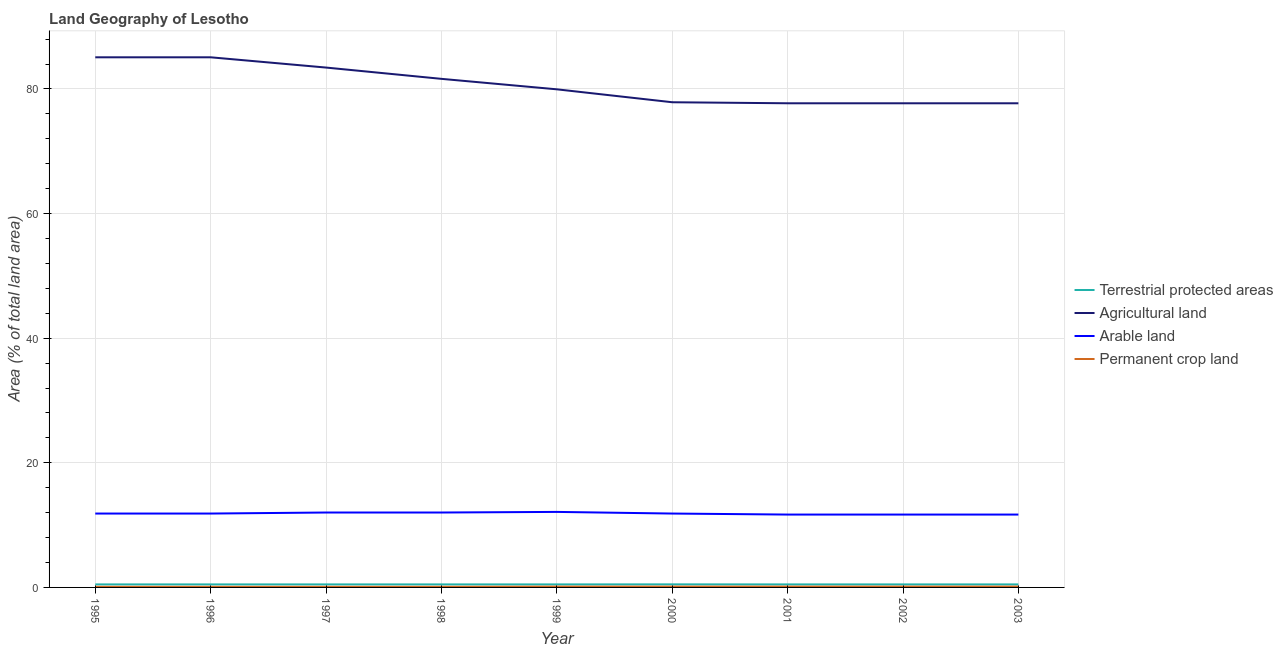How many different coloured lines are there?
Offer a very short reply. 4. Is the number of lines equal to the number of legend labels?
Your response must be concise. Yes. What is the percentage of area under agricultural land in 2002?
Offer a terse response. 77.7. Across all years, what is the maximum percentage of area under permanent crop land?
Your answer should be compact. 0.13. Across all years, what is the minimum percentage of area under agricultural land?
Your response must be concise. 77.7. In which year was the percentage of area under agricultural land maximum?
Offer a terse response. 1995. What is the total percentage of area under permanent crop land in the graph?
Provide a succinct answer. 1.05. What is the difference between the percentage of area under agricultural land in 2001 and that in 2003?
Keep it short and to the point. 0. What is the difference between the percentage of area under permanent crop land in 1996 and the percentage of area under agricultural land in 2003?
Your response must be concise. -77.6. What is the average percentage of area under arable land per year?
Offer a very short reply. 11.87. In the year 1995, what is the difference between the percentage of area under arable land and percentage of area under permanent crop land?
Provide a short and direct response. 11.76. What is the ratio of the percentage of area under agricultural land in 1996 to that in 2002?
Keep it short and to the point. 1.09. Is the difference between the percentage of area under permanent crop land in 1998 and 1999 greater than the difference between the percentage of area under arable land in 1998 and 1999?
Keep it short and to the point. Yes. What is the difference between the highest and the second highest percentage of land under terrestrial protection?
Offer a very short reply. 0.01. What is the difference between the highest and the lowest percentage of land under terrestrial protection?
Provide a short and direct response. 0.01. Is it the case that in every year, the sum of the percentage of land under terrestrial protection and percentage of area under agricultural land is greater than the percentage of area under arable land?
Keep it short and to the point. Yes. Is the percentage of area under arable land strictly greater than the percentage of area under agricultural land over the years?
Make the answer very short. No. Is the percentage of area under agricultural land strictly less than the percentage of land under terrestrial protection over the years?
Provide a succinct answer. No. How many lines are there?
Provide a succinct answer. 4. How many years are there in the graph?
Your response must be concise. 9. What is the difference between two consecutive major ticks on the Y-axis?
Offer a terse response. 20. Does the graph contain grids?
Your response must be concise. Yes. Where does the legend appear in the graph?
Provide a short and direct response. Center right. How many legend labels are there?
Ensure brevity in your answer.  4. What is the title of the graph?
Your answer should be compact. Land Geography of Lesotho. Does "Ease of arranging shipments" appear as one of the legend labels in the graph?
Offer a very short reply. No. What is the label or title of the Y-axis?
Offer a very short reply. Area (% of total land area). What is the Area (% of total land area) in Terrestrial protected areas in 1995?
Provide a succinct answer. 0.49. What is the Area (% of total land area) of Agricultural land in 1995?
Keep it short and to the point. 85.08. What is the Area (% of total land area) in Arable land in 1995?
Offer a terse response. 11.86. What is the Area (% of total land area) in Permanent crop land in 1995?
Offer a terse response. 0.1. What is the Area (% of total land area) of Terrestrial protected areas in 1996?
Offer a very short reply. 0.49. What is the Area (% of total land area) of Agricultural land in 1996?
Offer a very short reply. 85.08. What is the Area (% of total land area) of Arable land in 1996?
Ensure brevity in your answer.  11.86. What is the Area (% of total land area) in Permanent crop land in 1996?
Ensure brevity in your answer.  0.1. What is the Area (% of total land area) in Terrestrial protected areas in 1997?
Offer a terse response. 0.49. What is the Area (% of total land area) in Agricultural land in 1997?
Offer a terse response. 83.43. What is the Area (% of total land area) of Arable land in 1997?
Offer a terse response. 12.02. What is the Area (% of total land area) of Permanent crop land in 1997?
Offer a very short reply. 0.1. What is the Area (% of total land area) in Terrestrial protected areas in 1998?
Offer a very short reply. 0.49. What is the Area (% of total land area) in Agricultural land in 1998?
Give a very brief answer. 81.62. What is the Area (% of total land area) of Arable land in 1998?
Make the answer very short. 12.02. What is the Area (% of total land area) in Permanent crop land in 1998?
Keep it short and to the point. 0.1. What is the Area (% of total land area) in Terrestrial protected areas in 1999?
Your answer should be compact. 0.49. What is the Area (% of total land area) of Agricultural land in 1999?
Offer a terse response. 79.94. What is the Area (% of total land area) of Arable land in 1999?
Provide a succinct answer. 12.12. What is the Area (% of total land area) of Permanent crop land in 1999?
Make the answer very short. 0.13. What is the Area (% of total land area) of Terrestrial protected areas in 2000?
Make the answer very short. 0.49. What is the Area (% of total land area) in Agricultural land in 2000?
Make the answer very short. 77.87. What is the Area (% of total land area) in Arable land in 2000?
Your response must be concise. 11.86. What is the Area (% of total land area) of Permanent crop land in 2000?
Ensure brevity in your answer.  0.13. What is the Area (% of total land area) of Terrestrial protected areas in 2001?
Make the answer very short. 0.49. What is the Area (% of total land area) in Agricultural land in 2001?
Your answer should be compact. 77.7. What is the Area (% of total land area) of Arable land in 2001?
Make the answer very short. 11.69. What is the Area (% of total land area) in Permanent crop land in 2001?
Ensure brevity in your answer.  0.13. What is the Area (% of total land area) in Terrestrial protected areas in 2002?
Provide a succinct answer. 0.49. What is the Area (% of total land area) of Agricultural land in 2002?
Offer a terse response. 77.7. What is the Area (% of total land area) of Arable land in 2002?
Offer a very short reply. 11.69. What is the Area (% of total land area) in Permanent crop land in 2002?
Your response must be concise. 0.13. What is the Area (% of total land area) in Terrestrial protected areas in 2003?
Offer a terse response. 0.49. What is the Area (% of total land area) of Agricultural land in 2003?
Offer a very short reply. 77.7. What is the Area (% of total land area) in Arable land in 2003?
Your response must be concise. 11.69. What is the Area (% of total land area) in Permanent crop land in 2003?
Keep it short and to the point. 0.13. Across all years, what is the maximum Area (% of total land area) of Terrestrial protected areas?
Make the answer very short. 0.49. Across all years, what is the maximum Area (% of total land area) in Agricultural land?
Your response must be concise. 85.08. Across all years, what is the maximum Area (% of total land area) in Arable land?
Your response must be concise. 12.12. Across all years, what is the maximum Area (% of total land area) of Permanent crop land?
Provide a short and direct response. 0.13. Across all years, what is the minimum Area (% of total land area) in Terrestrial protected areas?
Your response must be concise. 0.49. Across all years, what is the minimum Area (% of total land area) in Agricultural land?
Your answer should be compact. 77.7. Across all years, what is the minimum Area (% of total land area) in Arable land?
Your response must be concise. 11.69. Across all years, what is the minimum Area (% of total land area) in Permanent crop land?
Give a very brief answer. 0.1. What is the total Area (% of total land area) in Terrestrial protected areas in the graph?
Your answer should be compact. 4.37. What is the total Area (% of total land area) in Agricultural land in the graph?
Your response must be concise. 726.12. What is the total Area (% of total land area) in Arable land in the graph?
Make the answer very short. 106.82. What is the total Area (% of total land area) of Permanent crop land in the graph?
Ensure brevity in your answer.  1.05. What is the difference between the Area (% of total land area) in Terrestrial protected areas in 1995 and that in 1996?
Make the answer very short. 0. What is the difference between the Area (% of total land area) in Permanent crop land in 1995 and that in 1996?
Provide a short and direct response. 0. What is the difference between the Area (% of total land area) of Agricultural land in 1995 and that in 1997?
Offer a terse response. 1.65. What is the difference between the Area (% of total land area) of Arable land in 1995 and that in 1997?
Your answer should be very brief. -0.16. What is the difference between the Area (% of total land area) in Permanent crop land in 1995 and that in 1997?
Keep it short and to the point. 0. What is the difference between the Area (% of total land area) in Agricultural land in 1995 and that in 1998?
Your response must be concise. 3.46. What is the difference between the Area (% of total land area) of Arable land in 1995 and that in 1998?
Provide a succinct answer. -0.16. What is the difference between the Area (% of total land area) in Agricultural land in 1995 and that in 1999?
Your response must be concise. 5.14. What is the difference between the Area (% of total land area) in Arable land in 1995 and that in 1999?
Your answer should be compact. -0.26. What is the difference between the Area (% of total land area) in Permanent crop land in 1995 and that in 1999?
Your response must be concise. -0.03. What is the difference between the Area (% of total land area) in Terrestrial protected areas in 1995 and that in 2000?
Provide a short and direct response. -0.01. What is the difference between the Area (% of total land area) in Agricultural land in 1995 and that in 2000?
Offer a terse response. 7.21. What is the difference between the Area (% of total land area) in Permanent crop land in 1995 and that in 2000?
Provide a succinct answer. -0.03. What is the difference between the Area (% of total land area) of Terrestrial protected areas in 1995 and that in 2001?
Your response must be concise. 0. What is the difference between the Area (% of total land area) in Agricultural land in 1995 and that in 2001?
Make the answer very short. 7.38. What is the difference between the Area (% of total land area) of Arable land in 1995 and that in 2001?
Provide a succinct answer. 0.16. What is the difference between the Area (% of total land area) of Permanent crop land in 1995 and that in 2001?
Give a very brief answer. -0.03. What is the difference between the Area (% of total land area) of Agricultural land in 1995 and that in 2002?
Keep it short and to the point. 7.38. What is the difference between the Area (% of total land area) in Arable land in 1995 and that in 2002?
Provide a short and direct response. 0.16. What is the difference between the Area (% of total land area) of Permanent crop land in 1995 and that in 2002?
Your response must be concise. -0.03. What is the difference between the Area (% of total land area) in Agricultural land in 1995 and that in 2003?
Give a very brief answer. 7.38. What is the difference between the Area (% of total land area) in Arable land in 1995 and that in 2003?
Make the answer very short. 0.16. What is the difference between the Area (% of total land area) of Permanent crop land in 1995 and that in 2003?
Ensure brevity in your answer.  -0.03. What is the difference between the Area (% of total land area) of Agricultural land in 1996 and that in 1997?
Keep it short and to the point. 1.65. What is the difference between the Area (% of total land area) of Arable land in 1996 and that in 1997?
Make the answer very short. -0.16. What is the difference between the Area (% of total land area) in Terrestrial protected areas in 1996 and that in 1998?
Offer a terse response. 0. What is the difference between the Area (% of total land area) of Agricultural land in 1996 and that in 1998?
Provide a succinct answer. 3.46. What is the difference between the Area (% of total land area) in Arable land in 1996 and that in 1998?
Your answer should be compact. -0.16. What is the difference between the Area (% of total land area) of Permanent crop land in 1996 and that in 1998?
Offer a terse response. 0. What is the difference between the Area (% of total land area) in Terrestrial protected areas in 1996 and that in 1999?
Ensure brevity in your answer.  0. What is the difference between the Area (% of total land area) of Agricultural land in 1996 and that in 1999?
Offer a terse response. 5.14. What is the difference between the Area (% of total land area) of Arable land in 1996 and that in 1999?
Your answer should be compact. -0.26. What is the difference between the Area (% of total land area) in Permanent crop land in 1996 and that in 1999?
Make the answer very short. -0.03. What is the difference between the Area (% of total land area) of Terrestrial protected areas in 1996 and that in 2000?
Your response must be concise. -0.01. What is the difference between the Area (% of total land area) of Agricultural land in 1996 and that in 2000?
Your answer should be compact. 7.21. What is the difference between the Area (% of total land area) of Arable land in 1996 and that in 2000?
Offer a terse response. 0. What is the difference between the Area (% of total land area) of Permanent crop land in 1996 and that in 2000?
Offer a very short reply. -0.03. What is the difference between the Area (% of total land area) of Terrestrial protected areas in 1996 and that in 2001?
Offer a very short reply. 0. What is the difference between the Area (% of total land area) of Agricultural land in 1996 and that in 2001?
Your answer should be compact. 7.38. What is the difference between the Area (% of total land area) of Arable land in 1996 and that in 2001?
Keep it short and to the point. 0.16. What is the difference between the Area (% of total land area) of Permanent crop land in 1996 and that in 2001?
Keep it short and to the point. -0.03. What is the difference between the Area (% of total land area) in Agricultural land in 1996 and that in 2002?
Your answer should be very brief. 7.38. What is the difference between the Area (% of total land area) of Arable land in 1996 and that in 2002?
Give a very brief answer. 0.16. What is the difference between the Area (% of total land area) in Permanent crop land in 1996 and that in 2002?
Give a very brief answer. -0.03. What is the difference between the Area (% of total land area) in Terrestrial protected areas in 1996 and that in 2003?
Your response must be concise. 0. What is the difference between the Area (% of total land area) in Agricultural land in 1996 and that in 2003?
Keep it short and to the point. 7.38. What is the difference between the Area (% of total land area) in Arable land in 1996 and that in 2003?
Ensure brevity in your answer.  0.16. What is the difference between the Area (% of total land area) in Permanent crop land in 1996 and that in 2003?
Your answer should be compact. -0.03. What is the difference between the Area (% of total land area) of Terrestrial protected areas in 1997 and that in 1998?
Keep it short and to the point. 0. What is the difference between the Area (% of total land area) of Agricultural land in 1997 and that in 1998?
Your answer should be very brief. 1.81. What is the difference between the Area (% of total land area) in Arable land in 1997 and that in 1998?
Your answer should be very brief. 0. What is the difference between the Area (% of total land area) in Permanent crop land in 1997 and that in 1998?
Provide a succinct answer. 0. What is the difference between the Area (% of total land area) in Terrestrial protected areas in 1997 and that in 1999?
Provide a short and direct response. 0. What is the difference between the Area (% of total land area) of Agricultural land in 1997 and that in 1999?
Your answer should be very brief. 3.49. What is the difference between the Area (% of total land area) of Arable land in 1997 and that in 1999?
Offer a very short reply. -0.1. What is the difference between the Area (% of total land area) in Permanent crop land in 1997 and that in 1999?
Provide a short and direct response. -0.03. What is the difference between the Area (% of total land area) in Terrestrial protected areas in 1997 and that in 2000?
Offer a terse response. -0.01. What is the difference between the Area (% of total land area) of Agricultural land in 1997 and that in 2000?
Offer a very short reply. 5.57. What is the difference between the Area (% of total land area) in Arable land in 1997 and that in 2000?
Provide a succinct answer. 0.16. What is the difference between the Area (% of total land area) in Permanent crop land in 1997 and that in 2000?
Offer a terse response. -0.03. What is the difference between the Area (% of total land area) of Terrestrial protected areas in 1997 and that in 2001?
Provide a succinct answer. 0. What is the difference between the Area (% of total land area) in Agricultural land in 1997 and that in 2001?
Provide a short and direct response. 5.73. What is the difference between the Area (% of total land area) in Arable land in 1997 and that in 2001?
Your response must be concise. 0.33. What is the difference between the Area (% of total land area) in Permanent crop land in 1997 and that in 2001?
Your response must be concise. -0.03. What is the difference between the Area (% of total land area) of Agricultural land in 1997 and that in 2002?
Your answer should be very brief. 5.73. What is the difference between the Area (% of total land area) in Arable land in 1997 and that in 2002?
Your answer should be compact. 0.33. What is the difference between the Area (% of total land area) of Permanent crop land in 1997 and that in 2002?
Offer a very short reply. -0.03. What is the difference between the Area (% of total land area) in Terrestrial protected areas in 1997 and that in 2003?
Ensure brevity in your answer.  0. What is the difference between the Area (% of total land area) of Agricultural land in 1997 and that in 2003?
Provide a succinct answer. 5.73. What is the difference between the Area (% of total land area) of Arable land in 1997 and that in 2003?
Your answer should be very brief. 0.33. What is the difference between the Area (% of total land area) of Permanent crop land in 1997 and that in 2003?
Provide a short and direct response. -0.03. What is the difference between the Area (% of total land area) of Agricultural land in 1998 and that in 1999?
Give a very brief answer. 1.68. What is the difference between the Area (% of total land area) of Arable land in 1998 and that in 1999?
Your answer should be very brief. -0.1. What is the difference between the Area (% of total land area) of Permanent crop land in 1998 and that in 1999?
Make the answer very short. -0.03. What is the difference between the Area (% of total land area) in Terrestrial protected areas in 1998 and that in 2000?
Provide a succinct answer. -0.01. What is the difference between the Area (% of total land area) in Agricultural land in 1998 and that in 2000?
Give a very brief answer. 3.75. What is the difference between the Area (% of total land area) in Arable land in 1998 and that in 2000?
Ensure brevity in your answer.  0.16. What is the difference between the Area (% of total land area) in Permanent crop land in 1998 and that in 2000?
Offer a terse response. -0.03. What is the difference between the Area (% of total land area) in Agricultural land in 1998 and that in 2001?
Offer a terse response. 3.92. What is the difference between the Area (% of total land area) of Arable land in 1998 and that in 2001?
Give a very brief answer. 0.33. What is the difference between the Area (% of total land area) in Permanent crop land in 1998 and that in 2001?
Offer a very short reply. -0.03. What is the difference between the Area (% of total land area) of Agricultural land in 1998 and that in 2002?
Provide a succinct answer. 3.92. What is the difference between the Area (% of total land area) in Arable land in 1998 and that in 2002?
Give a very brief answer. 0.33. What is the difference between the Area (% of total land area) of Permanent crop land in 1998 and that in 2002?
Provide a succinct answer. -0.03. What is the difference between the Area (% of total land area) in Agricultural land in 1998 and that in 2003?
Your response must be concise. 3.92. What is the difference between the Area (% of total land area) of Arable land in 1998 and that in 2003?
Make the answer very short. 0.33. What is the difference between the Area (% of total land area) of Permanent crop land in 1998 and that in 2003?
Your answer should be compact. -0.03. What is the difference between the Area (% of total land area) in Terrestrial protected areas in 1999 and that in 2000?
Provide a succinct answer. -0.01. What is the difference between the Area (% of total land area) in Agricultural land in 1999 and that in 2000?
Provide a succinct answer. 2.08. What is the difference between the Area (% of total land area) in Arable land in 1999 and that in 2000?
Give a very brief answer. 0.26. What is the difference between the Area (% of total land area) of Agricultural land in 1999 and that in 2001?
Offer a terse response. 2.24. What is the difference between the Area (% of total land area) of Arable land in 1999 and that in 2001?
Offer a very short reply. 0.43. What is the difference between the Area (% of total land area) of Terrestrial protected areas in 1999 and that in 2002?
Your response must be concise. 0. What is the difference between the Area (% of total land area) in Agricultural land in 1999 and that in 2002?
Offer a terse response. 2.24. What is the difference between the Area (% of total land area) of Arable land in 1999 and that in 2002?
Provide a succinct answer. 0.43. What is the difference between the Area (% of total land area) of Terrestrial protected areas in 1999 and that in 2003?
Provide a succinct answer. 0. What is the difference between the Area (% of total land area) in Agricultural land in 1999 and that in 2003?
Make the answer very short. 2.24. What is the difference between the Area (% of total land area) in Arable land in 1999 and that in 2003?
Provide a short and direct response. 0.43. What is the difference between the Area (% of total land area) of Terrestrial protected areas in 2000 and that in 2001?
Ensure brevity in your answer.  0.01. What is the difference between the Area (% of total land area) of Agricultural land in 2000 and that in 2001?
Provide a succinct answer. 0.16. What is the difference between the Area (% of total land area) of Arable land in 2000 and that in 2001?
Offer a terse response. 0.16. What is the difference between the Area (% of total land area) of Permanent crop land in 2000 and that in 2001?
Your answer should be very brief. 0. What is the difference between the Area (% of total land area) of Terrestrial protected areas in 2000 and that in 2002?
Provide a short and direct response. 0.01. What is the difference between the Area (% of total land area) in Agricultural land in 2000 and that in 2002?
Offer a very short reply. 0.16. What is the difference between the Area (% of total land area) in Arable land in 2000 and that in 2002?
Offer a very short reply. 0.16. What is the difference between the Area (% of total land area) of Terrestrial protected areas in 2000 and that in 2003?
Offer a terse response. 0.01. What is the difference between the Area (% of total land area) of Agricultural land in 2000 and that in 2003?
Provide a succinct answer. 0.16. What is the difference between the Area (% of total land area) in Arable land in 2000 and that in 2003?
Ensure brevity in your answer.  0.16. What is the difference between the Area (% of total land area) in Permanent crop land in 2001 and that in 2002?
Offer a very short reply. 0. What is the difference between the Area (% of total land area) in Terrestrial protected areas in 2001 and that in 2003?
Offer a terse response. 0. What is the difference between the Area (% of total land area) of Agricultural land in 2001 and that in 2003?
Provide a succinct answer. 0. What is the difference between the Area (% of total land area) in Permanent crop land in 2001 and that in 2003?
Give a very brief answer. 0. What is the difference between the Area (% of total land area) of Arable land in 2002 and that in 2003?
Your answer should be compact. 0. What is the difference between the Area (% of total land area) in Permanent crop land in 2002 and that in 2003?
Offer a very short reply. 0. What is the difference between the Area (% of total land area) in Terrestrial protected areas in 1995 and the Area (% of total land area) in Agricultural land in 1996?
Offer a terse response. -84.59. What is the difference between the Area (% of total land area) in Terrestrial protected areas in 1995 and the Area (% of total land area) in Arable land in 1996?
Ensure brevity in your answer.  -11.37. What is the difference between the Area (% of total land area) of Terrestrial protected areas in 1995 and the Area (% of total land area) of Permanent crop land in 1996?
Your answer should be very brief. 0.39. What is the difference between the Area (% of total land area) of Agricultural land in 1995 and the Area (% of total land area) of Arable land in 1996?
Offer a terse response. 73.22. What is the difference between the Area (% of total land area) of Agricultural land in 1995 and the Area (% of total land area) of Permanent crop land in 1996?
Keep it short and to the point. 84.98. What is the difference between the Area (% of total land area) of Arable land in 1995 and the Area (% of total land area) of Permanent crop land in 1996?
Offer a terse response. 11.76. What is the difference between the Area (% of total land area) in Terrestrial protected areas in 1995 and the Area (% of total land area) in Agricultural land in 1997?
Ensure brevity in your answer.  -82.95. What is the difference between the Area (% of total land area) of Terrestrial protected areas in 1995 and the Area (% of total land area) of Arable land in 1997?
Your answer should be compact. -11.54. What is the difference between the Area (% of total land area) in Terrestrial protected areas in 1995 and the Area (% of total land area) in Permanent crop land in 1997?
Keep it short and to the point. 0.39. What is the difference between the Area (% of total land area) of Agricultural land in 1995 and the Area (% of total land area) of Arable land in 1997?
Ensure brevity in your answer.  73.06. What is the difference between the Area (% of total land area) in Agricultural land in 1995 and the Area (% of total land area) in Permanent crop land in 1997?
Provide a succinct answer. 84.98. What is the difference between the Area (% of total land area) of Arable land in 1995 and the Area (% of total land area) of Permanent crop land in 1997?
Give a very brief answer. 11.76. What is the difference between the Area (% of total land area) in Terrestrial protected areas in 1995 and the Area (% of total land area) in Agricultural land in 1998?
Make the answer very short. -81.14. What is the difference between the Area (% of total land area) in Terrestrial protected areas in 1995 and the Area (% of total land area) in Arable land in 1998?
Provide a succinct answer. -11.54. What is the difference between the Area (% of total land area) of Terrestrial protected areas in 1995 and the Area (% of total land area) of Permanent crop land in 1998?
Your answer should be compact. 0.39. What is the difference between the Area (% of total land area) in Agricultural land in 1995 and the Area (% of total land area) in Arable land in 1998?
Offer a very short reply. 73.06. What is the difference between the Area (% of total land area) of Agricultural land in 1995 and the Area (% of total land area) of Permanent crop land in 1998?
Keep it short and to the point. 84.98. What is the difference between the Area (% of total land area) in Arable land in 1995 and the Area (% of total land area) in Permanent crop land in 1998?
Offer a very short reply. 11.76. What is the difference between the Area (% of total land area) in Terrestrial protected areas in 1995 and the Area (% of total land area) in Agricultural land in 1999?
Provide a succinct answer. -79.46. What is the difference between the Area (% of total land area) of Terrestrial protected areas in 1995 and the Area (% of total land area) of Arable land in 1999?
Offer a terse response. -11.64. What is the difference between the Area (% of total land area) in Terrestrial protected areas in 1995 and the Area (% of total land area) in Permanent crop land in 1999?
Provide a short and direct response. 0.35. What is the difference between the Area (% of total land area) of Agricultural land in 1995 and the Area (% of total land area) of Arable land in 1999?
Your answer should be compact. 72.96. What is the difference between the Area (% of total land area) in Agricultural land in 1995 and the Area (% of total land area) in Permanent crop land in 1999?
Offer a terse response. 84.95. What is the difference between the Area (% of total land area) of Arable land in 1995 and the Area (% of total land area) of Permanent crop land in 1999?
Keep it short and to the point. 11.73. What is the difference between the Area (% of total land area) of Terrestrial protected areas in 1995 and the Area (% of total land area) of Agricultural land in 2000?
Keep it short and to the point. -77.38. What is the difference between the Area (% of total land area) in Terrestrial protected areas in 1995 and the Area (% of total land area) in Arable land in 2000?
Your response must be concise. -11.37. What is the difference between the Area (% of total land area) in Terrestrial protected areas in 1995 and the Area (% of total land area) in Permanent crop land in 2000?
Keep it short and to the point. 0.35. What is the difference between the Area (% of total land area) of Agricultural land in 1995 and the Area (% of total land area) of Arable land in 2000?
Provide a succinct answer. 73.22. What is the difference between the Area (% of total land area) in Agricultural land in 1995 and the Area (% of total land area) in Permanent crop land in 2000?
Make the answer very short. 84.95. What is the difference between the Area (% of total land area) in Arable land in 1995 and the Area (% of total land area) in Permanent crop land in 2000?
Offer a terse response. 11.73. What is the difference between the Area (% of total land area) of Terrestrial protected areas in 1995 and the Area (% of total land area) of Agricultural land in 2001?
Keep it short and to the point. -77.22. What is the difference between the Area (% of total land area) of Terrestrial protected areas in 1995 and the Area (% of total land area) of Arable land in 2001?
Give a very brief answer. -11.21. What is the difference between the Area (% of total land area) in Terrestrial protected areas in 1995 and the Area (% of total land area) in Permanent crop land in 2001?
Provide a succinct answer. 0.35. What is the difference between the Area (% of total land area) in Agricultural land in 1995 and the Area (% of total land area) in Arable land in 2001?
Give a very brief answer. 73.39. What is the difference between the Area (% of total land area) of Agricultural land in 1995 and the Area (% of total land area) of Permanent crop land in 2001?
Keep it short and to the point. 84.95. What is the difference between the Area (% of total land area) in Arable land in 1995 and the Area (% of total land area) in Permanent crop land in 2001?
Offer a terse response. 11.73. What is the difference between the Area (% of total land area) in Terrestrial protected areas in 1995 and the Area (% of total land area) in Agricultural land in 2002?
Your answer should be very brief. -77.22. What is the difference between the Area (% of total land area) of Terrestrial protected areas in 1995 and the Area (% of total land area) of Arable land in 2002?
Provide a short and direct response. -11.21. What is the difference between the Area (% of total land area) of Terrestrial protected areas in 1995 and the Area (% of total land area) of Permanent crop land in 2002?
Offer a very short reply. 0.35. What is the difference between the Area (% of total land area) of Agricultural land in 1995 and the Area (% of total land area) of Arable land in 2002?
Offer a terse response. 73.39. What is the difference between the Area (% of total land area) of Agricultural land in 1995 and the Area (% of total land area) of Permanent crop land in 2002?
Your answer should be very brief. 84.95. What is the difference between the Area (% of total land area) of Arable land in 1995 and the Area (% of total land area) of Permanent crop land in 2002?
Offer a terse response. 11.73. What is the difference between the Area (% of total land area) of Terrestrial protected areas in 1995 and the Area (% of total land area) of Agricultural land in 2003?
Give a very brief answer. -77.22. What is the difference between the Area (% of total land area) of Terrestrial protected areas in 1995 and the Area (% of total land area) of Arable land in 2003?
Provide a short and direct response. -11.21. What is the difference between the Area (% of total land area) of Terrestrial protected areas in 1995 and the Area (% of total land area) of Permanent crop land in 2003?
Provide a succinct answer. 0.35. What is the difference between the Area (% of total land area) of Agricultural land in 1995 and the Area (% of total land area) of Arable land in 2003?
Offer a terse response. 73.39. What is the difference between the Area (% of total land area) in Agricultural land in 1995 and the Area (% of total land area) in Permanent crop land in 2003?
Provide a short and direct response. 84.95. What is the difference between the Area (% of total land area) in Arable land in 1995 and the Area (% of total land area) in Permanent crop land in 2003?
Ensure brevity in your answer.  11.73. What is the difference between the Area (% of total land area) of Terrestrial protected areas in 1996 and the Area (% of total land area) of Agricultural land in 1997?
Your answer should be very brief. -82.95. What is the difference between the Area (% of total land area) in Terrestrial protected areas in 1996 and the Area (% of total land area) in Arable land in 1997?
Your answer should be compact. -11.54. What is the difference between the Area (% of total land area) of Terrestrial protected areas in 1996 and the Area (% of total land area) of Permanent crop land in 1997?
Provide a short and direct response. 0.39. What is the difference between the Area (% of total land area) of Agricultural land in 1996 and the Area (% of total land area) of Arable land in 1997?
Offer a terse response. 73.06. What is the difference between the Area (% of total land area) in Agricultural land in 1996 and the Area (% of total land area) in Permanent crop land in 1997?
Make the answer very short. 84.98. What is the difference between the Area (% of total land area) of Arable land in 1996 and the Area (% of total land area) of Permanent crop land in 1997?
Your response must be concise. 11.76. What is the difference between the Area (% of total land area) in Terrestrial protected areas in 1996 and the Area (% of total land area) in Agricultural land in 1998?
Give a very brief answer. -81.14. What is the difference between the Area (% of total land area) of Terrestrial protected areas in 1996 and the Area (% of total land area) of Arable land in 1998?
Offer a terse response. -11.54. What is the difference between the Area (% of total land area) in Terrestrial protected areas in 1996 and the Area (% of total land area) in Permanent crop land in 1998?
Keep it short and to the point. 0.39. What is the difference between the Area (% of total land area) of Agricultural land in 1996 and the Area (% of total land area) of Arable land in 1998?
Your answer should be very brief. 73.06. What is the difference between the Area (% of total land area) in Agricultural land in 1996 and the Area (% of total land area) in Permanent crop land in 1998?
Provide a short and direct response. 84.98. What is the difference between the Area (% of total land area) of Arable land in 1996 and the Area (% of total land area) of Permanent crop land in 1998?
Ensure brevity in your answer.  11.76. What is the difference between the Area (% of total land area) in Terrestrial protected areas in 1996 and the Area (% of total land area) in Agricultural land in 1999?
Your answer should be very brief. -79.46. What is the difference between the Area (% of total land area) in Terrestrial protected areas in 1996 and the Area (% of total land area) in Arable land in 1999?
Your response must be concise. -11.64. What is the difference between the Area (% of total land area) of Terrestrial protected areas in 1996 and the Area (% of total land area) of Permanent crop land in 1999?
Keep it short and to the point. 0.35. What is the difference between the Area (% of total land area) of Agricultural land in 1996 and the Area (% of total land area) of Arable land in 1999?
Your answer should be compact. 72.96. What is the difference between the Area (% of total land area) of Agricultural land in 1996 and the Area (% of total land area) of Permanent crop land in 1999?
Give a very brief answer. 84.95. What is the difference between the Area (% of total land area) of Arable land in 1996 and the Area (% of total land area) of Permanent crop land in 1999?
Offer a very short reply. 11.73. What is the difference between the Area (% of total land area) in Terrestrial protected areas in 1996 and the Area (% of total land area) in Agricultural land in 2000?
Provide a succinct answer. -77.38. What is the difference between the Area (% of total land area) in Terrestrial protected areas in 1996 and the Area (% of total land area) in Arable land in 2000?
Your answer should be compact. -11.37. What is the difference between the Area (% of total land area) of Terrestrial protected areas in 1996 and the Area (% of total land area) of Permanent crop land in 2000?
Provide a short and direct response. 0.35. What is the difference between the Area (% of total land area) in Agricultural land in 1996 and the Area (% of total land area) in Arable land in 2000?
Your answer should be very brief. 73.22. What is the difference between the Area (% of total land area) in Agricultural land in 1996 and the Area (% of total land area) in Permanent crop land in 2000?
Your response must be concise. 84.95. What is the difference between the Area (% of total land area) of Arable land in 1996 and the Area (% of total land area) of Permanent crop land in 2000?
Offer a terse response. 11.73. What is the difference between the Area (% of total land area) of Terrestrial protected areas in 1996 and the Area (% of total land area) of Agricultural land in 2001?
Offer a terse response. -77.22. What is the difference between the Area (% of total land area) in Terrestrial protected areas in 1996 and the Area (% of total land area) in Arable land in 2001?
Offer a very short reply. -11.21. What is the difference between the Area (% of total land area) in Terrestrial protected areas in 1996 and the Area (% of total land area) in Permanent crop land in 2001?
Make the answer very short. 0.35. What is the difference between the Area (% of total land area) of Agricultural land in 1996 and the Area (% of total land area) of Arable land in 2001?
Offer a very short reply. 73.39. What is the difference between the Area (% of total land area) of Agricultural land in 1996 and the Area (% of total land area) of Permanent crop land in 2001?
Your response must be concise. 84.95. What is the difference between the Area (% of total land area) of Arable land in 1996 and the Area (% of total land area) of Permanent crop land in 2001?
Ensure brevity in your answer.  11.73. What is the difference between the Area (% of total land area) of Terrestrial protected areas in 1996 and the Area (% of total land area) of Agricultural land in 2002?
Offer a very short reply. -77.22. What is the difference between the Area (% of total land area) of Terrestrial protected areas in 1996 and the Area (% of total land area) of Arable land in 2002?
Provide a succinct answer. -11.21. What is the difference between the Area (% of total land area) of Terrestrial protected areas in 1996 and the Area (% of total land area) of Permanent crop land in 2002?
Your answer should be compact. 0.35. What is the difference between the Area (% of total land area) of Agricultural land in 1996 and the Area (% of total land area) of Arable land in 2002?
Give a very brief answer. 73.39. What is the difference between the Area (% of total land area) of Agricultural land in 1996 and the Area (% of total land area) of Permanent crop land in 2002?
Give a very brief answer. 84.95. What is the difference between the Area (% of total land area) in Arable land in 1996 and the Area (% of total land area) in Permanent crop land in 2002?
Your answer should be very brief. 11.73. What is the difference between the Area (% of total land area) in Terrestrial protected areas in 1996 and the Area (% of total land area) in Agricultural land in 2003?
Make the answer very short. -77.22. What is the difference between the Area (% of total land area) of Terrestrial protected areas in 1996 and the Area (% of total land area) of Arable land in 2003?
Provide a succinct answer. -11.21. What is the difference between the Area (% of total land area) of Terrestrial protected areas in 1996 and the Area (% of total land area) of Permanent crop land in 2003?
Offer a very short reply. 0.35. What is the difference between the Area (% of total land area) of Agricultural land in 1996 and the Area (% of total land area) of Arable land in 2003?
Ensure brevity in your answer.  73.39. What is the difference between the Area (% of total land area) of Agricultural land in 1996 and the Area (% of total land area) of Permanent crop land in 2003?
Give a very brief answer. 84.95. What is the difference between the Area (% of total land area) in Arable land in 1996 and the Area (% of total land area) in Permanent crop land in 2003?
Make the answer very short. 11.73. What is the difference between the Area (% of total land area) of Terrestrial protected areas in 1997 and the Area (% of total land area) of Agricultural land in 1998?
Your answer should be compact. -81.14. What is the difference between the Area (% of total land area) of Terrestrial protected areas in 1997 and the Area (% of total land area) of Arable land in 1998?
Your answer should be very brief. -11.54. What is the difference between the Area (% of total land area) of Terrestrial protected areas in 1997 and the Area (% of total land area) of Permanent crop land in 1998?
Provide a short and direct response. 0.39. What is the difference between the Area (% of total land area) of Agricultural land in 1997 and the Area (% of total land area) of Arable land in 1998?
Your answer should be very brief. 71.41. What is the difference between the Area (% of total land area) in Agricultural land in 1997 and the Area (% of total land area) in Permanent crop land in 1998?
Ensure brevity in your answer.  83.33. What is the difference between the Area (% of total land area) of Arable land in 1997 and the Area (% of total land area) of Permanent crop land in 1998?
Offer a very short reply. 11.92. What is the difference between the Area (% of total land area) in Terrestrial protected areas in 1997 and the Area (% of total land area) in Agricultural land in 1999?
Give a very brief answer. -79.46. What is the difference between the Area (% of total land area) of Terrestrial protected areas in 1997 and the Area (% of total land area) of Arable land in 1999?
Provide a short and direct response. -11.64. What is the difference between the Area (% of total land area) of Terrestrial protected areas in 1997 and the Area (% of total land area) of Permanent crop land in 1999?
Offer a very short reply. 0.35. What is the difference between the Area (% of total land area) in Agricultural land in 1997 and the Area (% of total land area) in Arable land in 1999?
Offer a terse response. 71.31. What is the difference between the Area (% of total land area) in Agricultural land in 1997 and the Area (% of total land area) in Permanent crop land in 1999?
Offer a very short reply. 83.3. What is the difference between the Area (% of total land area) in Arable land in 1997 and the Area (% of total land area) in Permanent crop land in 1999?
Offer a terse response. 11.89. What is the difference between the Area (% of total land area) of Terrestrial protected areas in 1997 and the Area (% of total land area) of Agricultural land in 2000?
Ensure brevity in your answer.  -77.38. What is the difference between the Area (% of total land area) of Terrestrial protected areas in 1997 and the Area (% of total land area) of Arable land in 2000?
Offer a terse response. -11.37. What is the difference between the Area (% of total land area) in Terrestrial protected areas in 1997 and the Area (% of total land area) in Permanent crop land in 2000?
Provide a short and direct response. 0.35. What is the difference between the Area (% of total land area) of Agricultural land in 1997 and the Area (% of total land area) of Arable land in 2000?
Keep it short and to the point. 71.57. What is the difference between the Area (% of total land area) of Agricultural land in 1997 and the Area (% of total land area) of Permanent crop land in 2000?
Keep it short and to the point. 83.3. What is the difference between the Area (% of total land area) in Arable land in 1997 and the Area (% of total land area) in Permanent crop land in 2000?
Your answer should be compact. 11.89. What is the difference between the Area (% of total land area) in Terrestrial protected areas in 1997 and the Area (% of total land area) in Agricultural land in 2001?
Provide a short and direct response. -77.22. What is the difference between the Area (% of total land area) in Terrestrial protected areas in 1997 and the Area (% of total land area) in Arable land in 2001?
Provide a short and direct response. -11.21. What is the difference between the Area (% of total land area) in Terrestrial protected areas in 1997 and the Area (% of total land area) in Permanent crop land in 2001?
Provide a short and direct response. 0.35. What is the difference between the Area (% of total land area) of Agricultural land in 1997 and the Area (% of total land area) of Arable land in 2001?
Offer a terse response. 71.74. What is the difference between the Area (% of total land area) of Agricultural land in 1997 and the Area (% of total land area) of Permanent crop land in 2001?
Offer a very short reply. 83.3. What is the difference between the Area (% of total land area) in Arable land in 1997 and the Area (% of total land area) in Permanent crop land in 2001?
Make the answer very short. 11.89. What is the difference between the Area (% of total land area) in Terrestrial protected areas in 1997 and the Area (% of total land area) in Agricultural land in 2002?
Offer a terse response. -77.22. What is the difference between the Area (% of total land area) in Terrestrial protected areas in 1997 and the Area (% of total land area) in Arable land in 2002?
Your answer should be compact. -11.21. What is the difference between the Area (% of total land area) in Terrestrial protected areas in 1997 and the Area (% of total land area) in Permanent crop land in 2002?
Provide a succinct answer. 0.35. What is the difference between the Area (% of total land area) in Agricultural land in 1997 and the Area (% of total land area) in Arable land in 2002?
Offer a terse response. 71.74. What is the difference between the Area (% of total land area) in Agricultural land in 1997 and the Area (% of total land area) in Permanent crop land in 2002?
Keep it short and to the point. 83.3. What is the difference between the Area (% of total land area) in Arable land in 1997 and the Area (% of total land area) in Permanent crop land in 2002?
Offer a terse response. 11.89. What is the difference between the Area (% of total land area) of Terrestrial protected areas in 1997 and the Area (% of total land area) of Agricultural land in 2003?
Offer a terse response. -77.22. What is the difference between the Area (% of total land area) of Terrestrial protected areas in 1997 and the Area (% of total land area) of Arable land in 2003?
Provide a succinct answer. -11.21. What is the difference between the Area (% of total land area) in Terrestrial protected areas in 1997 and the Area (% of total land area) in Permanent crop land in 2003?
Your answer should be compact. 0.35. What is the difference between the Area (% of total land area) in Agricultural land in 1997 and the Area (% of total land area) in Arable land in 2003?
Make the answer very short. 71.74. What is the difference between the Area (% of total land area) of Agricultural land in 1997 and the Area (% of total land area) of Permanent crop land in 2003?
Your response must be concise. 83.3. What is the difference between the Area (% of total land area) in Arable land in 1997 and the Area (% of total land area) in Permanent crop land in 2003?
Ensure brevity in your answer.  11.89. What is the difference between the Area (% of total land area) in Terrestrial protected areas in 1998 and the Area (% of total land area) in Agricultural land in 1999?
Give a very brief answer. -79.46. What is the difference between the Area (% of total land area) in Terrestrial protected areas in 1998 and the Area (% of total land area) in Arable land in 1999?
Give a very brief answer. -11.64. What is the difference between the Area (% of total land area) in Terrestrial protected areas in 1998 and the Area (% of total land area) in Permanent crop land in 1999?
Ensure brevity in your answer.  0.35. What is the difference between the Area (% of total land area) in Agricultural land in 1998 and the Area (% of total land area) in Arable land in 1999?
Your response must be concise. 69.5. What is the difference between the Area (% of total land area) of Agricultural land in 1998 and the Area (% of total land area) of Permanent crop land in 1999?
Provide a short and direct response. 81.49. What is the difference between the Area (% of total land area) of Arable land in 1998 and the Area (% of total land area) of Permanent crop land in 1999?
Provide a short and direct response. 11.89. What is the difference between the Area (% of total land area) of Terrestrial protected areas in 1998 and the Area (% of total land area) of Agricultural land in 2000?
Offer a terse response. -77.38. What is the difference between the Area (% of total land area) of Terrestrial protected areas in 1998 and the Area (% of total land area) of Arable land in 2000?
Make the answer very short. -11.37. What is the difference between the Area (% of total land area) in Terrestrial protected areas in 1998 and the Area (% of total land area) in Permanent crop land in 2000?
Provide a succinct answer. 0.35. What is the difference between the Area (% of total land area) in Agricultural land in 1998 and the Area (% of total land area) in Arable land in 2000?
Give a very brief answer. 69.76. What is the difference between the Area (% of total land area) of Agricultural land in 1998 and the Area (% of total land area) of Permanent crop land in 2000?
Your answer should be very brief. 81.49. What is the difference between the Area (% of total land area) of Arable land in 1998 and the Area (% of total land area) of Permanent crop land in 2000?
Offer a very short reply. 11.89. What is the difference between the Area (% of total land area) in Terrestrial protected areas in 1998 and the Area (% of total land area) in Agricultural land in 2001?
Your answer should be very brief. -77.22. What is the difference between the Area (% of total land area) in Terrestrial protected areas in 1998 and the Area (% of total land area) in Arable land in 2001?
Your response must be concise. -11.21. What is the difference between the Area (% of total land area) in Terrestrial protected areas in 1998 and the Area (% of total land area) in Permanent crop land in 2001?
Your answer should be compact. 0.35. What is the difference between the Area (% of total land area) in Agricultural land in 1998 and the Area (% of total land area) in Arable land in 2001?
Your answer should be compact. 69.93. What is the difference between the Area (% of total land area) in Agricultural land in 1998 and the Area (% of total land area) in Permanent crop land in 2001?
Your answer should be very brief. 81.49. What is the difference between the Area (% of total land area) in Arable land in 1998 and the Area (% of total land area) in Permanent crop land in 2001?
Your answer should be compact. 11.89. What is the difference between the Area (% of total land area) of Terrestrial protected areas in 1998 and the Area (% of total land area) of Agricultural land in 2002?
Give a very brief answer. -77.22. What is the difference between the Area (% of total land area) in Terrestrial protected areas in 1998 and the Area (% of total land area) in Arable land in 2002?
Your answer should be very brief. -11.21. What is the difference between the Area (% of total land area) of Terrestrial protected areas in 1998 and the Area (% of total land area) of Permanent crop land in 2002?
Your answer should be very brief. 0.35. What is the difference between the Area (% of total land area) of Agricultural land in 1998 and the Area (% of total land area) of Arable land in 2002?
Offer a very short reply. 69.93. What is the difference between the Area (% of total land area) in Agricultural land in 1998 and the Area (% of total land area) in Permanent crop land in 2002?
Provide a short and direct response. 81.49. What is the difference between the Area (% of total land area) in Arable land in 1998 and the Area (% of total land area) in Permanent crop land in 2002?
Ensure brevity in your answer.  11.89. What is the difference between the Area (% of total land area) in Terrestrial protected areas in 1998 and the Area (% of total land area) in Agricultural land in 2003?
Provide a short and direct response. -77.22. What is the difference between the Area (% of total land area) of Terrestrial protected areas in 1998 and the Area (% of total land area) of Arable land in 2003?
Your answer should be very brief. -11.21. What is the difference between the Area (% of total land area) in Terrestrial protected areas in 1998 and the Area (% of total land area) in Permanent crop land in 2003?
Your answer should be compact. 0.35. What is the difference between the Area (% of total land area) of Agricultural land in 1998 and the Area (% of total land area) of Arable land in 2003?
Your answer should be very brief. 69.93. What is the difference between the Area (% of total land area) of Agricultural land in 1998 and the Area (% of total land area) of Permanent crop land in 2003?
Offer a very short reply. 81.49. What is the difference between the Area (% of total land area) of Arable land in 1998 and the Area (% of total land area) of Permanent crop land in 2003?
Your response must be concise. 11.89. What is the difference between the Area (% of total land area) of Terrestrial protected areas in 1999 and the Area (% of total land area) of Agricultural land in 2000?
Your answer should be compact. -77.38. What is the difference between the Area (% of total land area) in Terrestrial protected areas in 1999 and the Area (% of total land area) in Arable land in 2000?
Offer a very short reply. -11.37. What is the difference between the Area (% of total land area) of Terrestrial protected areas in 1999 and the Area (% of total land area) of Permanent crop land in 2000?
Ensure brevity in your answer.  0.35. What is the difference between the Area (% of total land area) in Agricultural land in 1999 and the Area (% of total land area) in Arable land in 2000?
Your answer should be compact. 68.08. What is the difference between the Area (% of total land area) of Agricultural land in 1999 and the Area (% of total land area) of Permanent crop land in 2000?
Provide a succinct answer. 79.81. What is the difference between the Area (% of total land area) of Arable land in 1999 and the Area (% of total land area) of Permanent crop land in 2000?
Your answer should be compact. 11.99. What is the difference between the Area (% of total land area) of Terrestrial protected areas in 1999 and the Area (% of total land area) of Agricultural land in 2001?
Your answer should be very brief. -77.22. What is the difference between the Area (% of total land area) of Terrestrial protected areas in 1999 and the Area (% of total land area) of Arable land in 2001?
Offer a very short reply. -11.21. What is the difference between the Area (% of total land area) in Terrestrial protected areas in 1999 and the Area (% of total land area) in Permanent crop land in 2001?
Your answer should be compact. 0.35. What is the difference between the Area (% of total land area) in Agricultural land in 1999 and the Area (% of total land area) in Arable land in 2001?
Make the answer very short. 68.25. What is the difference between the Area (% of total land area) of Agricultural land in 1999 and the Area (% of total land area) of Permanent crop land in 2001?
Offer a terse response. 79.81. What is the difference between the Area (% of total land area) in Arable land in 1999 and the Area (% of total land area) in Permanent crop land in 2001?
Provide a succinct answer. 11.99. What is the difference between the Area (% of total land area) of Terrestrial protected areas in 1999 and the Area (% of total land area) of Agricultural land in 2002?
Your answer should be very brief. -77.22. What is the difference between the Area (% of total land area) in Terrestrial protected areas in 1999 and the Area (% of total land area) in Arable land in 2002?
Your response must be concise. -11.21. What is the difference between the Area (% of total land area) of Terrestrial protected areas in 1999 and the Area (% of total land area) of Permanent crop land in 2002?
Your answer should be very brief. 0.35. What is the difference between the Area (% of total land area) in Agricultural land in 1999 and the Area (% of total land area) in Arable land in 2002?
Provide a succinct answer. 68.25. What is the difference between the Area (% of total land area) of Agricultural land in 1999 and the Area (% of total land area) of Permanent crop land in 2002?
Offer a terse response. 79.81. What is the difference between the Area (% of total land area) of Arable land in 1999 and the Area (% of total land area) of Permanent crop land in 2002?
Keep it short and to the point. 11.99. What is the difference between the Area (% of total land area) of Terrestrial protected areas in 1999 and the Area (% of total land area) of Agricultural land in 2003?
Your answer should be compact. -77.22. What is the difference between the Area (% of total land area) of Terrestrial protected areas in 1999 and the Area (% of total land area) of Arable land in 2003?
Your answer should be compact. -11.21. What is the difference between the Area (% of total land area) in Terrestrial protected areas in 1999 and the Area (% of total land area) in Permanent crop land in 2003?
Your answer should be compact. 0.35. What is the difference between the Area (% of total land area) of Agricultural land in 1999 and the Area (% of total land area) of Arable land in 2003?
Your response must be concise. 68.25. What is the difference between the Area (% of total land area) of Agricultural land in 1999 and the Area (% of total land area) of Permanent crop land in 2003?
Your answer should be compact. 79.81. What is the difference between the Area (% of total land area) in Arable land in 1999 and the Area (% of total land area) in Permanent crop land in 2003?
Your answer should be very brief. 11.99. What is the difference between the Area (% of total land area) of Terrestrial protected areas in 2000 and the Area (% of total land area) of Agricultural land in 2001?
Offer a terse response. -77.21. What is the difference between the Area (% of total land area) of Terrestrial protected areas in 2000 and the Area (% of total land area) of Arable land in 2001?
Give a very brief answer. -11.2. What is the difference between the Area (% of total land area) of Terrestrial protected areas in 2000 and the Area (% of total land area) of Permanent crop land in 2001?
Your answer should be very brief. 0.36. What is the difference between the Area (% of total land area) in Agricultural land in 2000 and the Area (% of total land area) in Arable land in 2001?
Your response must be concise. 66.17. What is the difference between the Area (% of total land area) of Agricultural land in 2000 and the Area (% of total land area) of Permanent crop land in 2001?
Offer a terse response. 77.73. What is the difference between the Area (% of total land area) of Arable land in 2000 and the Area (% of total land area) of Permanent crop land in 2001?
Offer a terse response. 11.73. What is the difference between the Area (% of total land area) of Terrestrial protected areas in 2000 and the Area (% of total land area) of Agricultural land in 2002?
Offer a terse response. -77.21. What is the difference between the Area (% of total land area) of Terrestrial protected areas in 2000 and the Area (% of total land area) of Arable land in 2002?
Your response must be concise. -11.2. What is the difference between the Area (% of total land area) of Terrestrial protected areas in 2000 and the Area (% of total land area) of Permanent crop land in 2002?
Keep it short and to the point. 0.36. What is the difference between the Area (% of total land area) in Agricultural land in 2000 and the Area (% of total land area) in Arable land in 2002?
Provide a short and direct response. 66.17. What is the difference between the Area (% of total land area) in Agricultural land in 2000 and the Area (% of total land area) in Permanent crop land in 2002?
Keep it short and to the point. 77.73. What is the difference between the Area (% of total land area) in Arable land in 2000 and the Area (% of total land area) in Permanent crop land in 2002?
Your answer should be compact. 11.73. What is the difference between the Area (% of total land area) of Terrestrial protected areas in 2000 and the Area (% of total land area) of Agricultural land in 2003?
Your response must be concise. -77.21. What is the difference between the Area (% of total land area) of Terrestrial protected areas in 2000 and the Area (% of total land area) of Arable land in 2003?
Provide a succinct answer. -11.2. What is the difference between the Area (% of total land area) in Terrestrial protected areas in 2000 and the Area (% of total land area) in Permanent crop land in 2003?
Provide a succinct answer. 0.36. What is the difference between the Area (% of total land area) in Agricultural land in 2000 and the Area (% of total land area) in Arable land in 2003?
Ensure brevity in your answer.  66.17. What is the difference between the Area (% of total land area) of Agricultural land in 2000 and the Area (% of total land area) of Permanent crop land in 2003?
Your answer should be very brief. 77.73. What is the difference between the Area (% of total land area) in Arable land in 2000 and the Area (% of total land area) in Permanent crop land in 2003?
Provide a short and direct response. 11.73. What is the difference between the Area (% of total land area) of Terrestrial protected areas in 2001 and the Area (% of total land area) of Agricultural land in 2002?
Ensure brevity in your answer.  -77.22. What is the difference between the Area (% of total land area) of Terrestrial protected areas in 2001 and the Area (% of total land area) of Arable land in 2002?
Ensure brevity in your answer.  -11.21. What is the difference between the Area (% of total land area) in Terrestrial protected areas in 2001 and the Area (% of total land area) in Permanent crop land in 2002?
Ensure brevity in your answer.  0.35. What is the difference between the Area (% of total land area) in Agricultural land in 2001 and the Area (% of total land area) in Arable land in 2002?
Ensure brevity in your answer.  66.01. What is the difference between the Area (% of total land area) of Agricultural land in 2001 and the Area (% of total land area) of Permanent crop land in 2002?
Ensure brevity in your answer.  77.57. What is the difference between the Area (% of total land area) in Arable land in 2001 and the Area (% of total land area) in Permanent crop land in 2002?
Ensure brevity in your answer.  11.56. What is the difference between the Area (% of total land area) in Terrestrial protected areas in 2001 and the Area (% of total land area) in Agricultural land in 2003?
Your response must be concise. -77.22. What is the difference between the Area (% of total land area) of Terrestrial protected areas in 2001 and the Area (% of total land area) of Arable land in 2003?
Your answer should be very brief. -11.21. What is the difference between the Area (% of total land area) of Terrestrial protected areas in 2001 and the Area (% of total land area) of Permanent crop land in 2003?
Your answer should be very brief. 0.35. What is the difference between the Area (% of total land area) of Agricultural land in 2001 and the Area (% of total land area) of Arable land in 2003?
Keep it short and to the point. 66.01. What is the difference between the Area (% of total land area) of Agricultural land in 2001 and the Area (% of total land area) of Permanent crop land in 2003?
Offer a very short reply. 77.57. What is the difference between the Area (% of total land area) in Arable land in 2001 and the Area (% of total land area) in Permanent crop land in 2003?
Your answer should be very brief. 11.56. What is the difference between the Area (% of total land area) of Terrestrial protected areas in 2002 and the Area (% of total land area) of Agricultural land in 2003?
Offer a very short reply. -77.22. What is the difference between the Area (% of total land area) of Terrestrial protected areas in 2002 and the Area (% of total land area) of Arable land in 2003?
Give a very brief answer. -11.21. What is the difference between the Area (% of total land area) of Terrestrial protected areas in 2002 and the Area (% of total land area) of Permanent crop land in 2003?
Keep it short and to the point. 0.35. What is the difference between the Area (% of total land area) in Agricultural land in 2002 and the Area (% of total land area) in Arable land in 2003?
Keep it short and to the point. 66.01. What is the difference between the Area (% of total land area) of Agricultural land in 2002 and the Area (% of total land area) of Permanent crop land in 2003?
Give a very brief answer. 77.57. What is the difference between the Area (% of total land area) of Arable land in 2002 and the Area (% of total land area) of Permanent crop land in 2003?
Offer a terse response. 11.56. What is the average Area (% of total land area) of Terrestrial protected areas per year?
Ensure brevity in your answer.  0.49. What is the average Area (% of total land area) of Agricultural land per year?
Your answer should be very brief. 80.68. What is the average Area (% of total land area) in Arable land per year?
Your answer should be very brief. 11.87. What is the average Area (% of total land area) of Permanent crop land per year?
Make the answer very short. 0.12. In the year 1995, what is the difference between the Area (% of total land area) in Terrestrial protected areas and Area (% of total land area) in Agricultural land?
Your answer should be very brief. -84.59. In the year 1995, what is the difference between the Area (% of total land area) of Terrestrial protected areas and Area (% of total land area) of Arable land?
Provide a short and direct response. -11.37. In the year 1995, what is the difference between the Area (% of total land area) of Terrestrial protected areas and Area (% of total land area) of Permanent crop land?
Make the answer very short. 0.39. In the year 1995, what is the difference between the Area (% of total land area) in Agricultural land and Area (% of total land area) in Arable land?
Provide a short and direct response. 73.22. In the year 1995, what is the difference between the Area (% of total land area) in Agricultural land and Area (% of total land area) in Permanent crop land?
Offer a terse response. 84.98. In the year 1995, what is the difference between the Area (% of total land area) in Arable land and Area (% of total land area) in Permanent crop land?
Offer a very short reply. 11.76. In the year 1996, what is the difference between the Area (% of total land area) of Terrestrial protected areas and Area (% of total land area) of Agricultural land?
Provide a short and direct response. -84.59. In the year 1996, what is the difference between the Area (% of total land area) of Terrestrial protected areas and Area (% of total land area) of Arable land?
Make the answer very short. -11.37. In the year 1996, what is the difference between the Area (% of total land area) of Terrestrial protected areas and Area (% of total land area) of Permanent crop land?
Keep it short and to the point. 0.39. In the year 1996, what is the difference between the Area (% of total land area) in Agricultural land and Area (% of total land area) in Arable land?
Provide a succinct answer. 73.22. In the year 1996, what is the difference between the Area (% of total land area) of Agricultural land and Area (% of total land area) of Permanent crop land?
Offer a very short reply. 84.98. In the year 1996, what is the difference between the Area (% of total land area) of Arable land and Area (% of total land area) of Permanent crop land?
Your response must be concise. 11.76. In the year 1997, what is the difference between the Area (% of total land area) of Terrestrial protected areas and Area (% of total land area) of Agricultural land?
Make the answer very short. -82.95. In the year 1997, what is the difference between the Area (% of total land area) of Terrestrial protected areas and Area (% of total land area) of Arable land?
Ensure brevity in your answer.  -11.54. In the year 1997, what is the difference between the Area (% of total land area) in Terrestrial protected areas and Area (% of total land area) in Permanent crop land?
Make the answer very short. 0.39. In the year 1997, what is the difference between the Area (% of total land area) in Agricultural land and Area (% of total land area) in Arable land?
Your response must be concise. 71.41. In the year 1997, what is the difference between the Area (% of total land area) in Agricultural land and Area (% of total land area) in Permanent crop land?
Ensure brevity in your answer.  83.33. In the year 1997, what is the difference between the Area (% of total land area) of Arable land and Area (% of total land area) of Permanent crop land?
Keep it short and to the point. 11.92. In the year 1998, what is the difference between the Area (% of total land area) in Terrestrial protected areas and Area (% of total land area) in Agricultural land?
Keep it short and to the point. -81.14. In the year 1998, what is the difference between the Area (% of total land area) in Terrestrial protected areas and Area (% of total land area) in Arable land?
Your answer should be compact. -11.54. In the year 1998, what is the difference between the Area (% of total land area) of Terrestrial protected areas and Area (% of total land area) of Permanent crop land?
Give a very brief answer. 0.39. In the year 1998, what is the difference between the Area (% of total land area) in Agricultural land and Area (% of total land area) in Arable land?
Make the answer very short. 69.6. In the year 1998, what is the difference between the Area (% of total land area) of Agricultural land and Area (% of total land area) of Permanent crop land?
Your answer should be very brief. 81.52. In the year 1998, what is the difference between the Area (% of total land area) in Arable land and Area (% of total land area) in Permanent crop land?
Offer a terse response. 11.92. In the year 1999, what is the difference between the Area (% of total land area) of Terrestrial protected areas and Area (% of total land area) of Agricultural land?
Keep it short and to the point. -79.46. In the year 1999, what is the difference between the Area (% of total land area) of Terrestrial protected areas and Area (% of total land area) of Arable land?
Offer a very short reply. -11.64. In the year 1999, what is the difference between the Area (% of total land area) of Terrestrial protected areas and Area (% of total land area) of Permanent crop land?
Provide a short and direct response. 0.35. In the year 1999, what is the difference between the Area (% of total land area) in Agricultural land and Area (% of total land area) in Arable land?
Your answer should be very brief. 67.82. In the year 1999, what is the difference between the Area (% of total land area) of Agricultural land and Area (% of total land area) of Permanent crop land?
Provide a succinct answer. 79.81. In the year 1999, what is the difference between the Area (% of total land area) of Arable land and Area (% of total land area) of Permanent crop land?
Ensure brevity in your answer.  11.99. In the year 2000, what is the difference between the Area (% of total land area) of Terrestrial protected areas and Area (% of total land area) of Agricultural land?
Offer a terse response. -77.37. In the year 2000, what is the difference between the Area (% of total land area) of Terrestrial protected areas and Area (% of total land area) of Arable land?
Ensure brevity in your answer.  -11.37. In the year 2000, what is the difference between the Area (% of total land area) of Terrestrial protected areas and Area (% of total land area) of Permanent crop land?
Make the answer very short. 0.36. In the year 2000, what is the difference between the Area (% of total land area) of Agricultural land and Area (% of total land area) of Arable land?
Provide a short and direct response. 66.01. In the year 2000, what is the difference between the Area (% of total land area) in Agricultural land and Area (% of total land area) in Permanent crop land?
Give a very brief answer. 77.73. In the year 2000, what is the difference between the Area (% of total land area) in Arable land and Area (% of total land area) in Permanent crop land?
Your answer should be very brief. 11.73. In the year 2001, what is the difference between the Area (% of total land area) in Terrestrial protected areas and Area (% of total land area) in Agricultural land?
Provide a short and direct response. -77.22. In the year 2001, what is the difference between the Area (% of total land area) in Terrestrial protected areas and Area (% of total land area) in Arable land?
Your answer should be compact. -11.21. In the year 2001, what is the difference between the Area (% of total land area) in Terrestrial protected areas and Area (% of total land area) in Permanent crop land?
Your response must be concise. 0.35. In the year 2001, what is the difference between the Area (% of total land area) of Agricultural land and Area (% of total land area) of Arable land?
Offer a very short reply. 66.01. In the year 2001, what is the difference between the Area (% of total land area) of Agricultural land and Area (% of total land area) of Permanent crop land?
Make the answer very short. 77.57. In the year 2001, what is the difference between the Area (% of total land area) in Arable land and Area (% of total land area) in Permanent crop land?
Offer a very short reply. 11.56. In the year 2002, what is the difference between the Area (% of total land area) of Terrestrial protected areas and Area (% of total land area) of Agricultural land?
Make the answer very short. -77.22. In the year 2002, what is the difference between the Area (% of total land area) in Terrestrial protected areas and Area (% of total land area) in Arable land?
Offer a very short reply. -11.21. In the year 2002, what is the difference between the Area (% of total land area) in Terrestrial protected areas and Area (% of total land area) in Permanent crop land?
Keep it short and to the point. 0.35. In the year 2002, what is the difference between the Area (% of total land area) of Agricultural land and Area (% of total land area) of Arable land?
Make the answer very short. 66.01. In the year 2002, what is the difference between the Area (% of total land area) of Agricultural land and Area (% of total land area) of Permanent crop land?
Ensure brevity in your answer.  77.57. In the year 2002, what is the difference between the Area (% of total land area) in Arable land and Area (% of total land area) in Permanent crop land?
Offer a very short reply. 11.56. In the year 2003, what is the difference between the Area (% of total land area) of Terrestrial protected areas and Area (% of total land area) of Agricultural land?
Your answer should be compact. -77.22. In the year 2003, what is the difference between the Area (% of total land area) of Terrestrial protected areas and Area (% of total land area) of Arable land?
Provide a succinct answer. -11.21. In the year 2003, what is the difference between the Area (% of total land area) of Terrestrial protected areas and Area (% of total land area) of Permanent crop land?
Provide a succinct answer. 0.35. In the year 2003, what is the difference between the Area (% of total land area) in Agricultural land and Area (% of total land area) in Arable land?
Make the answer very short. 66.01. In the year 2003, what is the difference between the Area (% of total land area) of Agricultural land and Area (% of total land area) of Permanent crop land?
Your answer should be very brief. 77.57. In the year 2003, what is the difference between the Area (% of total land area) of Arable land and Area (% of total land area) of Permanent crop land?
Make the answer very short. 11.56. What is the ratio of the Area (% of total land area) in Arable land in 1995 to that in 1996?
Give a very brief answer. 1. What is the ratio of the Area (% of total land area) in Permanent crop land in 1995 to that in 1996?
Your response must be concise. 1. What is the ratio of the Area (% of total land area) of Terrestrial protected areas in 1995 to that in 1997?
Your response must be concise. 1. What is the ratio of the Area (% of total land area) in Agricultural land in 1995 to that in 1997?
Your answer should be compact. 1.02. What is the ratio of the Area (% of total land area) in Arable land in 1995 to that in 1997?
Provide a short and direct response. 0.99. What is the ratio of the Area (% of total land area) of Permanent crop land in 1995 to that in 1997?
Your response must be concise. 1. What is the ratio of the Area (% of total land area) of Agricultural land in 1995 to that in 1998?
Ensure brevity in your answer.  1.04. What is the ratio of the Area (% of total land area) of Arable land in 1995 to that in 1998?
Make the answer very short. 0.99. What is the ratio of the Area (% of total land area) of Agricultural land in 1995 to that in 1999?
Your answer should be compact. 1.06. What is the ratio of the Area (% of total land area) in Arable land in 1995 to that in 1999?
Keep it short and to the point. 0.98. What is the ratio of the Area (% of total land area) of Permanent crop land in 1995 to that in 1999?
Provide a succinct answer. 0.75. What is the ratio of the Area (% of total land area) of Terrestrial protected areas in 1995 to that in 2000?
Make the answer very short. 0.99. What is the ratio of the Area (% of total land area) in Agricultural land in 1995 to that in 2000?
Offer a terse response. 1.09. What is the ratio of the Area (% of total land area) in Arable land in 1995 to that in 2000?
Give a very brief answer. 1. What is the ratio of the Area (% of total land area) in Permanent crop land in 1995 to that in 2000?
Provide a succinct answer. 0.75. What is the ratio of the Area (% of total land area) of Agricultural land in 1995 to that in 2001?
Your answer should be compact. 1.09. What is the ratio of the Area (% of total land area) of Arable land in 1995 to that in 2001?
Give a very brief answer. 1.01. What is the ratio of the Area (% of total land area) of Permanent crop land in 1995 to that in 2001?
Offer a very short reply. 0.75. What is the ratio of the Area (% of total land area) of Terrestrial protected areas in 1995 to that in 2002?
Ensure brevity in your answer.  1. What is the ratio of the Area (% of total land area) in Agricultural land in 1995 to that in 2002?
Give a very brief answer. 1.09. What is the ratio of the Area (% of total land area) of Arable land in 1995 to that in 2002?
Keep it short and to the point. 1.01. What is the ratio of the Area (% of total land area) of Permanent crop land in 1995 to that in 2002?
Your answer should be very brief. 0.75. What is the ratio of the Area (% of total land area) of Agricultural land in 1995 to that in 2003?
Ensure brevity in your answer.  1.09. What is the ratio of the Area (% of total land area) of Arable land in 1995 to that in 2003?
Make the answer very short. 1.01. What is the ratio of the Area (% of total land area) of Permanent crop land in 1995 to that in 2003?
Offer a terse response. 0.75. What is the ratio of the Area (% of total land area) in Terrestrial protected areas in 1996 to that in 1997?
Provide a succinct answer. 1. What is the ratio of the Area (% of total land area) of Agricultural land in 1996 to that in 1997?
Keep it short and to the point. 1.02. What is the ratio of the Area (% of total land area) in Arable land in 1996 to that in 1997?
Provide a succinct answer. 0.99. What is the ratio of the Area (% of total land area) in Terrestrial protected areas in 1996 to that in 1998?
Provide a succinct answer. 1. What is the ratio of the Area (% of total land area) of Agricultural land in 1996 to that in 1998?
Give a very brief answer. 1.04. What is the ratio of the Area (% of total land area) in Arable land in 1996 to that in 1998?
Provide a short and direct response. 0.99. What is the ratio of the Area (% of total land area) of Permanent crop land in 1996 to that in 1998?
Your answer should be very brief. 1. What is the ratio of the Area (% of total land area) of Terrestrial protected areas in 1996 to that in 1999?
Provide a succinct answer. 1. What is the ratio of the Area (% of total land area) in Agricultural land in 1996 to that in 1999?
Provide a short and direct response. 1.06. What is the ratio of the Area (% of total land area) of Arable land in 1996 to that in 1999?
Your answer should be very brief. 0.98. What is the ratio of the Area (% of total land area) in Terrestrial protected areas in 1996 to that in 2000?
Your answer should be compact. 0.99. What is the ratio of the Area (% of total land area) of Agricultural land in 1996 to that in 2000?
Offer a very short reply. 1.09. What is the ratio of the Area (% of total land area) in Arable land in 1996 to that in 2000?
Provide a succinct answer. 1. What is the ratio of the Area (% of total land area) in Permanent crop land in 1996 to that in 2000?
Give a very brief answer. 0.75. What is the ratio of the Area (% of total land area) of Terrestrial protected areas in 1996 to that in 2001?
Offer a terse response. 1. What is the ratio of the Area (% of total land area) in Agricultural land in 1996 to that in 2001?
Your response must be concise. 1.09. What is the ratio of the Area (% of total land area) in Arable land in 1996 to that in 2001?
Provide a short and direct response. 1.01. What is the ratio of the Area (% of total land area) of Permanent crop land in 1996 to that in 2001?
Offer a very short reply. 0.75. What is the ratio of the Area (% of total land area) of Agricultural land in 1996 to that in 2002?
Provide a succinct answer. 1.09. What is the ratio of the Area (% of total land area) in Arable land in 1996 to that in 2002?
Provide a short and direct response. 1.01. What is the ratio of the Area (% of total land area) of Terrestrial protected areas in 1996 to that in 2003?
Provide a short and direct response. 1. What is the ratio of the Area (% of total land area) of Agricultural land in 1996 to that in 2003?
Offer a terse response. 1.09. What is the ratio of the Area (% of total land area) of Arable land in 1996 to that in 2003?
Offer a terse response. 1.01. What is the ratio of the Area (% of total land area) in Agricultural land in 1997 to that in 1998?
Make the answer very short. 1.02. What is the ratio of the Area (% of total land area) of Arable land in 1997 to that in 1998?
Your response must be concise. 1. What is the ratio of the Area (% of total land area) in Permanent crop land in 1997 to that in 1998?
Your response must be concise. 1. What is the ratio of the Area (% of total land area) in Terrestrial protected areas in 1997 to that in 1999?
Make the answer very short. 1. What is the ratio of the Area (% of total land area) of Agricultural land in 1997 to that in 1999?
Offer a terse response. 1.04. What is the ratio of the Area (% of total land area) in Arable land in 1997 to that in 1999?
Make the answer very short. 0.99. What is the ratio of the Area (% of total land area) in Terrestrial protected areas in 1997 to that in 2000?
Ensure brevity in your answer.  0.99. What is the ratio of the Area (% of total land area) of Agricultural land in 1997 to that in 2000?
Provide a short and direct response. 1.07. What is the ratio of the Area (% of total land area) of Arable land in 1997 to that in 2000?
Make the answer very short. 1.01. What is the ratio of the Area (% of total land area) of Permanent crop land in 1997 to that in 2000?
Ensure brevity in your answer.  0.75. What is the ratio of the Area (% of total land area) of Terrestrial protected areas in 1997 to that in 2001?
Keep it short and to the point. 1. What is the ratio of the Area (% of total land area) of Agricultural land in 1997 to that in 2001?
Give a very brief answer. 1.07. What is the ratio of the Area (% of total land area) in Arable land in 1997 to that in 2001?
Your answer should be compact. 1.03. What is the ratio of the Area (% of total land area) in Agricultural land in 1997 to that in 2002?
Your answer should be compact. 1.07. What is the ratio of the Area (% of total land area) in Arable land in 1997 to that in 2002?
Provide a succinct answer. 1.03. What is the ratio of the Area (% of total land area) in Terrestrial protected areas in 1997 to that in 2003?
Your response must be concise. 1. What is the ratio of the Area (% of total land area) in Agricultural land in 1997 to that in 2003?
Give a very brief answer. 1.07. What is the ratio of the Area (% of total land area) in Arable land in 1997 to that in 2003?
Offer a terse response. 1.03. What is the ratio of the Area (% of total land area) of Permanent crop land in 1997 to that in 2003?
Your answer should be compact. 0.75. What is the ratio of the Area (% of total land area) in Permanent crop land in 1998 to that in 1999?
Offer a very short reply. 0.75. What is the ratio of the Area (% of total land area) in Terrestrial protected areas in 1998 to that in 2000?
Give a very brief answer. 0.99. What is the ratio of the Area (% of total land area) in Agricultural land in 1998 to that in 2000?
Offer a terse response. 1.05. What is the ratio of the Area (% of total land area) of Arable land in 1998 to that in 2000?
Your answer should be compact. 1.01. What is the ratio of the Area (% of total land area) of Agricultural land in 1998 to that in 2001?
Provide a succinct answer. 1.05. What is the ratio of the Area (% of total land area) in Arable land in 1998 to that in 2001?
Your response must be concise. 1.03. What is the ratio of the Area (% of total land area) in Terrestrial protected areas in 1998 to that in 2002?
Your answer should be compact. 1. What is the ratio of the Area (% of total land area) in Agricultural land in 1998 to that in 2002?
Your answer should be compact. 1.05. What is the ratio of the Area (% of total land area) of Arable land in 1998 to that in 2002?
Make the answer very short. 1.03. What is the ratio of the Area (% of total land area) in Terrestrial protected areas in 1998 to that in 2003?
Offer a very short reply. 1. What is the ratio of the Area (% of total land area) in Agricultural land in 1998 to that in 2003?
Your response must be concise. 1.05. What is the ratio of the Area (% of total land area) in Arable land in 1998 to that in 2003?
Keep it short and to the point. 1.03. What is the ratio of the Area (% of total land area) in Terrestrial protected areas in 1999 to that in 2000?
Ensure brevity in your answer.  0.99. What is the ratio of the Area (% of total land area) in Agricultural land in 1999 to that in 2000?
Your answer should be compact. 1.03. What is the ratio of the Area (% of total land area) of Arable land in 1999 to that in 2000?
Offer a very short reply. 1.02. What is the ratio of the Area (% of total land area) of Terrestrial protected areas in 1999 to that in 2001?
Offer a very short reply. 1. What is the ratio of the Area (% of total land area) in Agricultural land in 1999 to that in 2001?
Offer a terse response. 1.03. What is the ratio of the Area (% of total land area) in Arable land in 1999 to that in 2001?
Provide a succinct answer. 1.04. What is the ratio of the Area (% of total land area) of Terrestrial protected areas in 1999 to that in 2002?
Keep it short and to the point. 1. What is the ratio of the Area (% of total land area) in Agricultural land in 1999 to that in 2002?
Ensure brevity in your answer.  1.03. What is the ratio of the Area (% of total land area) in Arable land in 1999 to that in 2002?
Your answer should be compact. 1.04. What is the ratio of the Area (% of total land area) of Terrestrial protected areas in 1999 to that in 2003?
Your response must be concise. 1. What is the ratio of the Area (% of total land area) in Agricultural land in 1999 to that in 2003?
Offer a terse response. 1.03. What is the ratio of the Area (% of total land area) in Arable land in 1999 to that in 2003?
Make the answer very short. 1.04. What is the ratio of the Area (% of total land area) in Terrestrial protected areas in 2000 to that in 2001?
Your answer should be very brief. 1.01. What is the ratio of the Area (% of total land area) of Agricultural land in 2000 to that in 2001?
Your answer should be very brief. 1. What is the ratio of the Area (% of total land area) of Arable land in 2000 to that in 2001?
Provide a short and direct response. 1.01. What is the ratio of the Area (% of total land area) in Terrestrial protected areas in 2000 to that in 2002?
Offer a very short reply. 1.01. What is the ratio of the Area (% of total land area) in Arable land in 2000 to that in 2002?
Your answer should be very brief. 1.01. What is the ratio of the Area (% of total land area) of Terrestrial protected areas in 2000 to that in 2003?
Offer a terse response. 1.01. What is the ratio of the Area (% of total land area) in Agricultural land in 2000 to that in 2003?
Your answer should be compact. 1. What is the ratio of the Area (% of total land area) in Arable land in 2000 to that in 2003?
Ensure brevity in your answer.  1.01. What is the ratio of the Area (% of total land area) of Permanent crop land in 2000 to that in 2003?
Offer a very short reply. 1. What is the ratio of the Area (% of total land area) of Agricultural land in 2001 to that in 2002?
Keep it short and to the point. 1. What is the ratio of the Area (% of total land area) in Permanent crop land in 2001 to that in 2002?
Provide a succinct answer. 1. What is the ratio of the Area (% of total land area) in Terrestrial protected areas in 2001 to that in 2003?
Ensure brevity in your answer.  1. What is the ratio of the Area (% of total land area) of Agricultural land in 2001 to that in 2003?
Provide a short and direct response. 1. What is the ratio of the Area (% of total land area) of Arable land in 2001 to that in 2003?
Make the answer very short. 1. What is the ratio of the Area (% of total land area) of Agricultural land in 2002 to that in 2003?
Ensure brevity in your answer.  1. What is the ratio of the Area (% of total land area) in Permanent crop land in 2002 to that in 2003?
Keep it short and to the point. 1. What is the difference between the highest and the second highest Area (% of total land area) of Terrestrial protected areas?
Give a very brief answer. 0.01. What is the difference between the highest and the second highest Area (% of total land area) in Agricultural land?
Give a very brief answer. 0. What is the difference between the highest and the second highest Area (% of total land area) in Arable land?
Make the answer very short. 0.1. What is the difference between the highest and the lowest Area (% of total land area) of Terrestrial protected areas?
Offer a very short reply. 0.01. What is the difference between the highest and the lowest Area (% of total land area) of Agricultural land?
Keep it short and to the point. 7.38. What is the difference between the highest and the lowest Area (% of total land area) in Arable land?
Provide a succinct answer. 0.43. What is the difference between the highest and the lowest Area (% of total land area) of Permanent crop land?
Offer a very short reply. 0.03. 